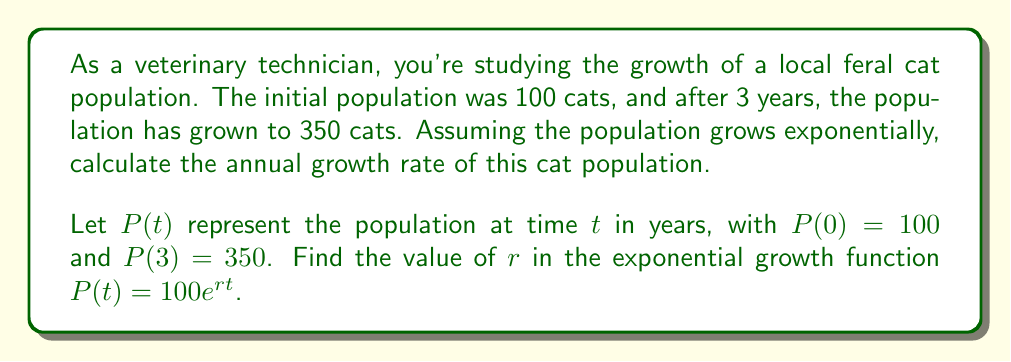Solve this math problem. To solve this problem, we'll use the exponential growth function and the given information:

1) The general form of the exponential growth function is:
   $$P(t) = P_0e^{rt}$$
   where $P_0$ is the initial population, $r$ is the growth rate, and $t$ is time.

2) We're given that $P_0 = 100$ and after 3 years, $P(3) = 350$. Let's substitute these into our equation:
   $$350 = 100e^{r(3)}$$

3) Divide both sides by 100:
   $$3.5 = e^{3r}$$

4) Take the natural logarithm of both sides:
   $$\ln(3.5) = \ln(e^{3r})$$

5) Simplify the right side using the properties of logarithms:
   $$\ln(3.5) = 3r$$

6) Solve for $r$:
   $$r = \frac{\ln(3.5)}{3}$$

7) Calculate the value of $r$:
   $$r \approx 0.4175$$

This means the annual growth rate is approximately 0.4175 or 41.75%.
Answer: The annual growth rate of the feral cat population is approximately 0.4175 or 41.75%. 